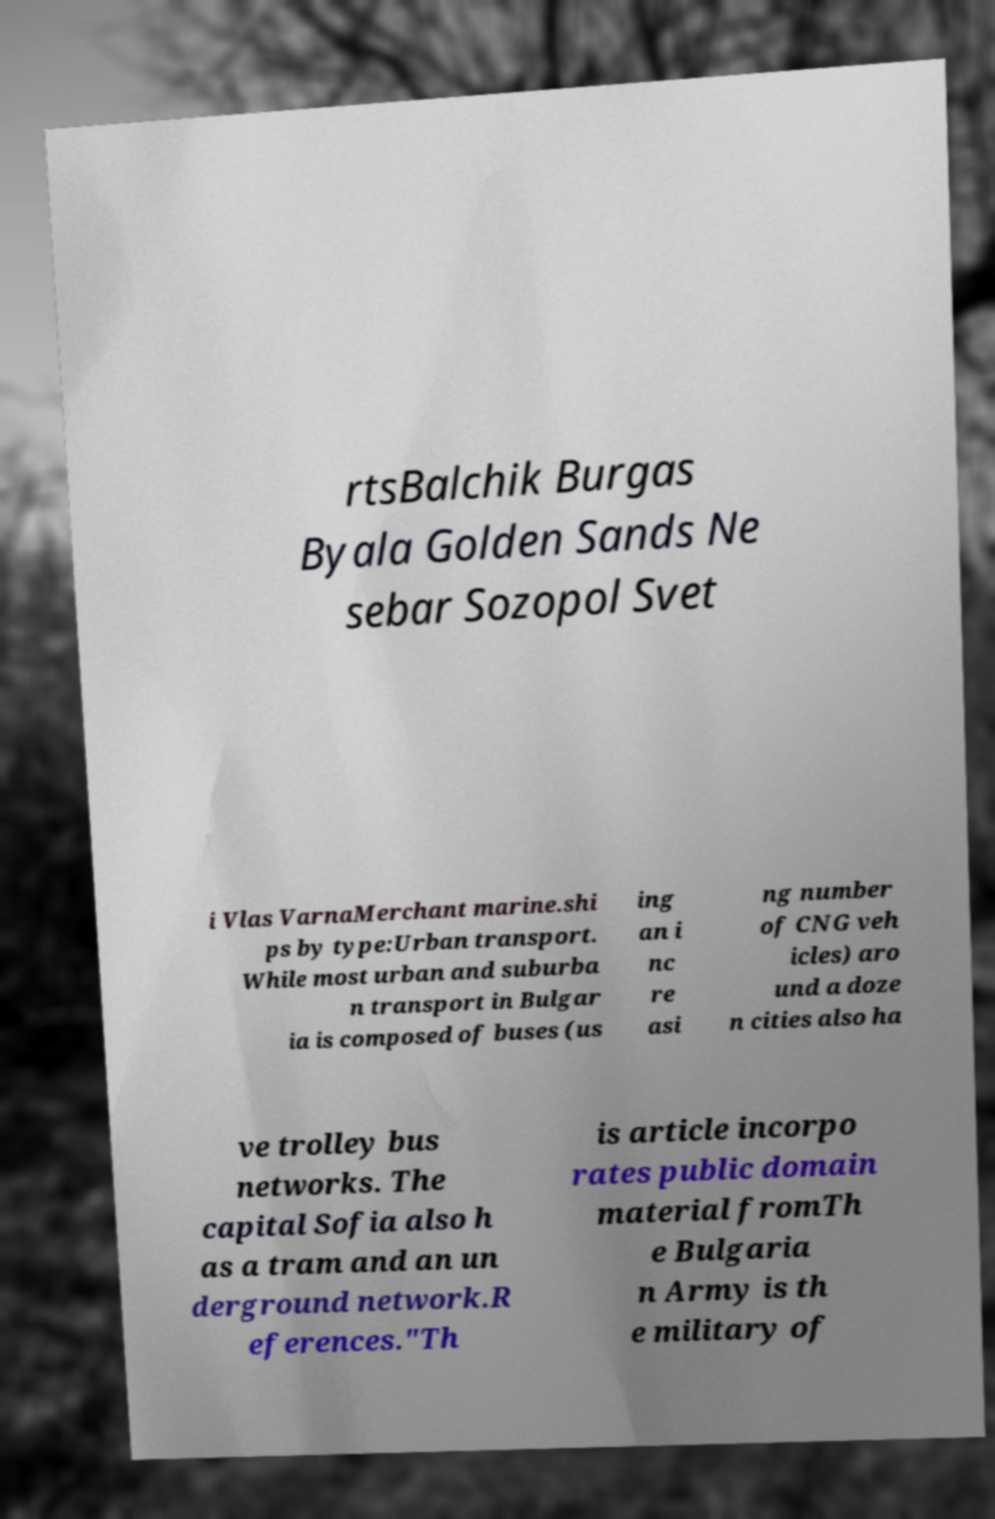I need the written content from this picture converted into text. Can you do that? rtsBalchik Burgas Byala Golden Sands Ne sebar Sozopol Svet i Vlas VarnaMerchant marine.shi ps by type:Urban transport. While most urban and suburba n transport in Bulgar ia is composed of buses (us ing an i nc re asi ng number of CNG veh icles) aro und a doze n cities also ha ve trolley bus networks. The capital Sofia also h as a tram and an un derground network.R eferences."Th is article incorpo rates public domain material fromTh e Bulgaria n Army is th e military of 